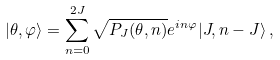Convert formula to latex. <formula><loc_0><loc_0><loc_500><loc_500>| \theta , \varphi \rangle = \sum _ { n = 0 } ^ { 2 J } { \sqrt { P _ { J } ( \theta , n ) } e ^ { i n \varphi } | J , n - J \rangle } \, ,</formula> 